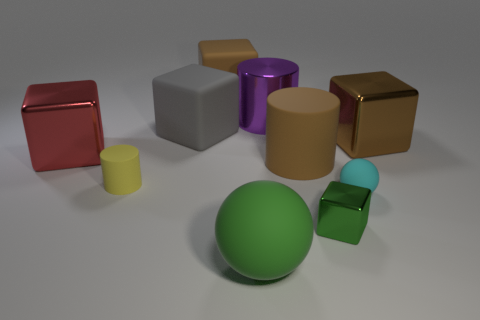Subtract 1 blocks. How many blocks are left? 4 Subtract all brown rubber cubes. How many cubes are left? 4 Subtract all gray blocks. How many blocks are left? 4 Subtract all yellow cubes. Subtract all green balls. How many cubes are left? 5 Subtract all cylinders. How many objects are left? 7 Add 1 cyan cylinders. How many cyan cylinders exist? 1 Subtract 0 green cylinders. How many objects are left? 10 Subtract all small brown matte things. Subtract all big shiny objects. How many objects are left? 7 Add 8 large brown metal things. How many large brown metal things are left? 9 